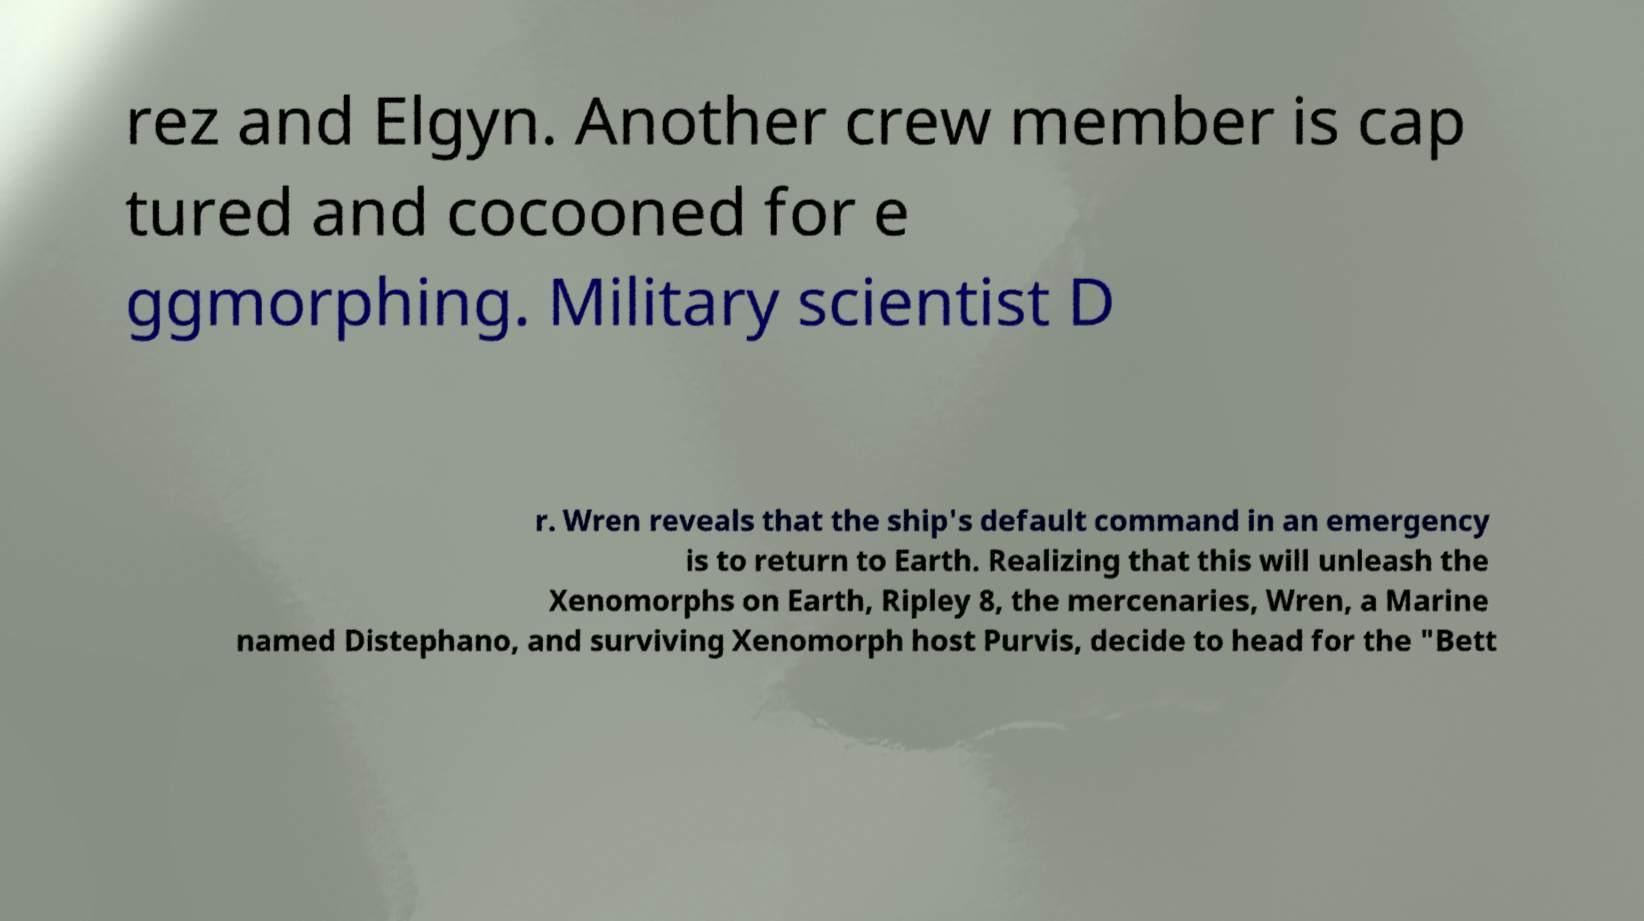What messages or text are displayed in this image? I need them in a readable, typed format. rez and Elgyn. Another crew member is cap tured and cocooned for e ggmorphing. Military scientist D r. Wren reveals that the ship's default command in an emergency is to return to Earth. Realizing that this will unleash the Xenomorphs on Earth, Ripley 8, the mercenaries, Wren, a Marine named Distephano, and surviving Xenomorph host Purvis, decide to head for the "Bett 